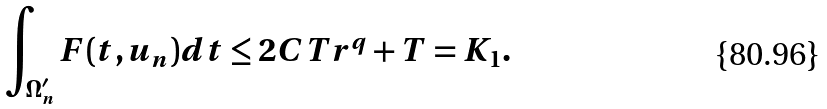<formula> <loc_0><loc_0><loc_500><loc_500>\int _ { \Omega ^ { \prime } _ { n } } F ( t , u _ { n } ) d t \leq 2 C T r ^ { q } + T = K _ { 1 } .</formula> 